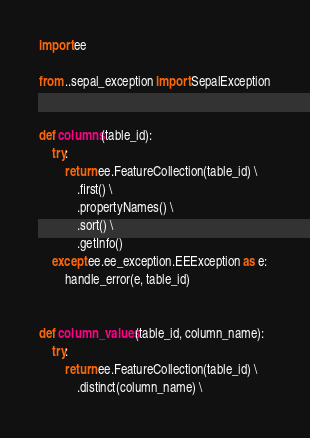Convert code to text. <code><loc_0><loc_0><loc_500><loc_500><_Python_>import ee

from ..sepal_exception import SepalException


def columns(table_id):
    try:
        return ee.FeatureCollection(table_id) \
            .first() \
            .propertyNames() \
            .sort() \
            .getInfo()
    except ee.ee_exception.EEException as e:
        handle_error(e, table_id)


def column_values(table_id, column_name):
    try:
        return ee.FeatureCollection(table_id) \
            .distinct(column_name) \</code> 